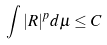Convert formula to latex. <formula><loc_0><loc_0><loc_500><loc_500>\int | R | ^ { p } d \mu \leq C</formula> 